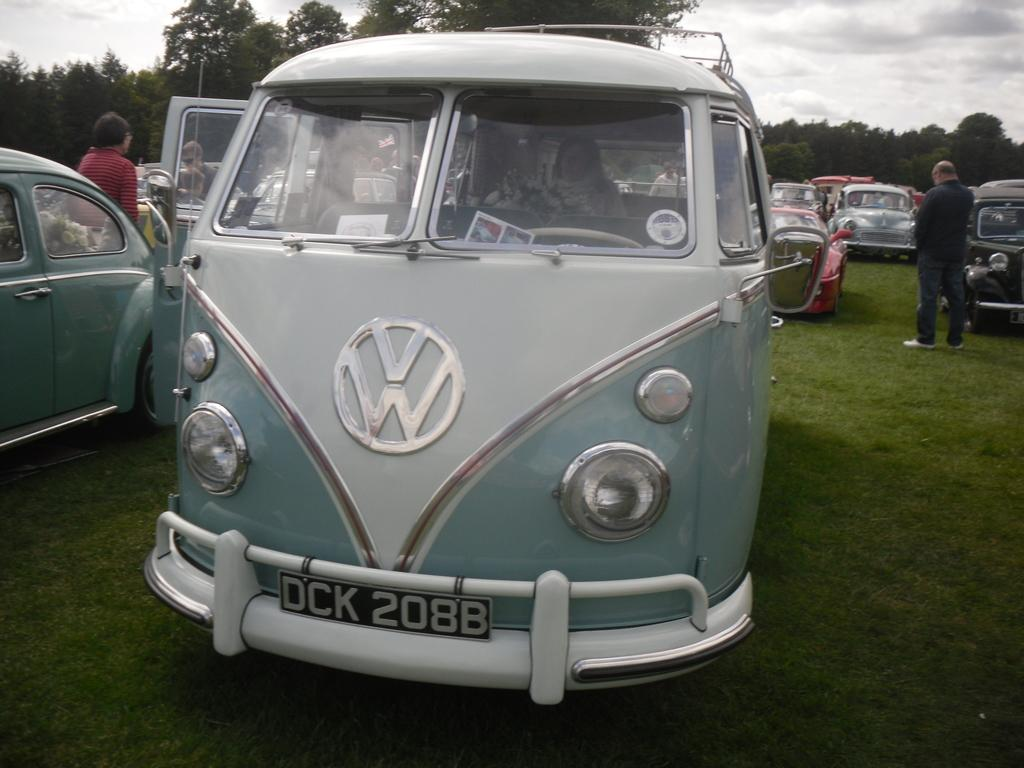<image>
Render a clear and concise summary of the photo. A blue and white classic Volkswagen is parked in the grass with several other classic cars. 